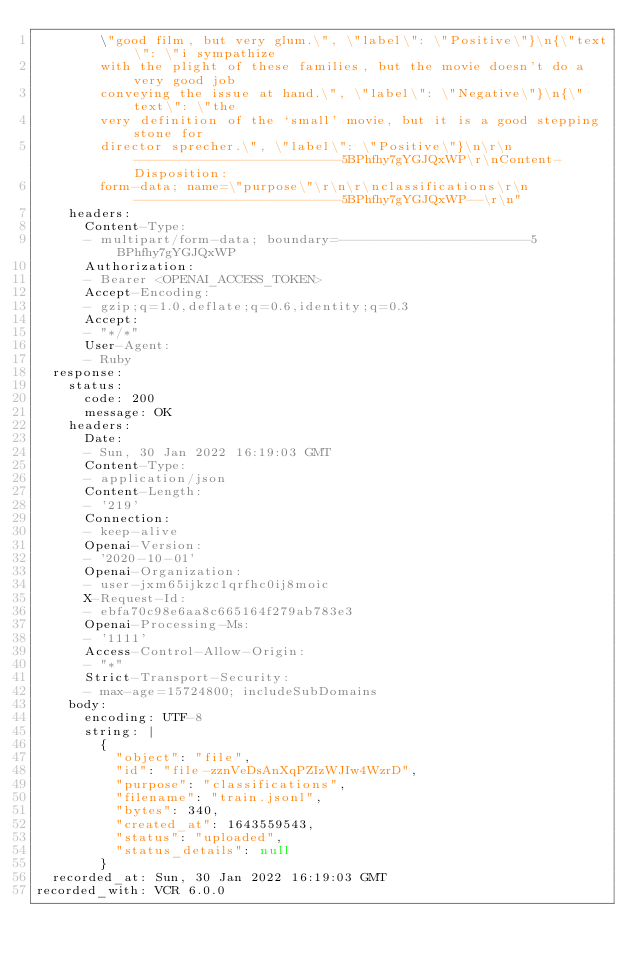<code> <loc_0><loc_0><loc_500><loc_500><_YAML_>        \"good film, but very glum.\", \"label\": \"Positive\"}\n{\"text\": \"i sympathize
        with the plight of these families, but the movie doesn't do a very good job
        conveying the issue at hand.\", \"label\": \"Negative\"}\n{\"text\": \"the
        very definition of the `small' movie, but it is a good stepping stone for
        director sprecher.\", \"label\": \"Positive\"}\n\r\n--------------------------5BPhfhy7gYGJQxWP\r\nContent-Disposition:
        form-data; name=\"purpose\"\r\n\r\nclassifications\r\n--------------------------5BPhfhy7gYGJQxWP--\r\n"
    headers:
      Content-Type:
      - multipart/form-data; boundary=------------------------5BPhfhy7gYGJQxWP
      Authorization:
      - Bearer <OPENAI_ACCESS_TOKEN>
      Accept-Encoding:
      - gzip;q=1.0,deflate;q=0.6,identity;q=0.3
      Accept:
      - "*/*"
      User-Agent:
      - Ruby
  response:
    status:
      code: 200
      message: OK
    headers:
      Date:
      - Sun, 30 Jan 2022 16:19:03 GMT
      Content-Type:
      - application/json
      Content-Length:
      - '219'
      Connection:
      - keep-alive
      Openai-Version:
      - '2020-10-01'
      Openai-Organization:
      - user-jxm65ijkzc1qrfhc0ij8moic
      X-Request-Id:
      - ebfa70c98e6aa8c665164f279ab783e3
      Openai-Processing-Ms:
      - '1111'
      Access-Control-Allow-Origin:
      - "*"
      Strict-Transport-Security:
      - max-age=15724800; includeSubDomains
    body:
      encoding: UTF-8
      string: |
        {
          "object": "file",
          "id": "file-zznVeDsAnXqPZIzWJIw4WzrD",
          "purpose": "classifications",
          "filename": "train.jsonl",
          "bytes": 340,
          "created_at": 1643559543,
          "status": "uploaded",
          "status_details": null
        }
  recorded_at: Sun, 30 Jan 2022 16:19:03 GMT
recorded_with: VCR 6.0.0
</code> 